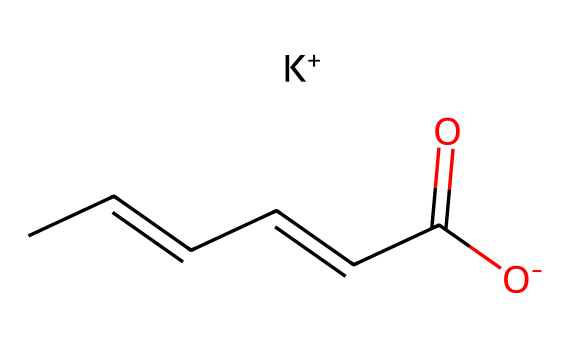What is the molecular formula of potassium sorbate? The SMILES provided indicates the presence of six carbon atoms (C6), eight hydrogen atoms (H8), one oxygen atom (O2), and one potassium atom (K). Thus, the molecular formula can be deduced as C6H7O2K.
Answer: C6H7O2K How many carbon atoms are present in the structure? By analyzing the SMILES notation, we see the sequence "CC=CC=CC" shows there are six carbon atoms connected in various forms (double bonds are present, but they still count as carbon atoms).
Answer: 6 What functional group is represented in potassium sorbate? The structure contains a carboxylate group (–COO−) as indicated by the presence of the carbon atom double bonded to oxygen and another oxygen with a negative charge. This characterizes it as a salt of a carboxylic acid.
Answer: carboxylate How many total atoms are in potassium sorbate's structure? From the molecular composition (C6H7O2K), we count the atoms: 6 carbon, 7 hydrogen, 2 oxygen, 1 potassium, resulting in 16 atoms in total.
Answer: 16 What is the charge of the sorbate ion in potassium sorbate? The sorbate ion in the structure contains a negative charge indicated by the notation "[O-]", which indicates that this oxygen is carrying a charge of -1.
Answer: -1 What type of preservation mechanism does potassium sorbate engage in? Potassium sorbate functions primarily by inhibiting the growth of molds and yeasts, which is critical for its use as a preservative in food items like wine and cheese.
Answer: inhibition What is the significance of the potassium ion in potassium sorbate? The presence of the potassium ion here enhances the solubility of sorbate in aqueous solutions, allowing it to be effectively utilized as a preservative in various food products.
Answer: solubility 